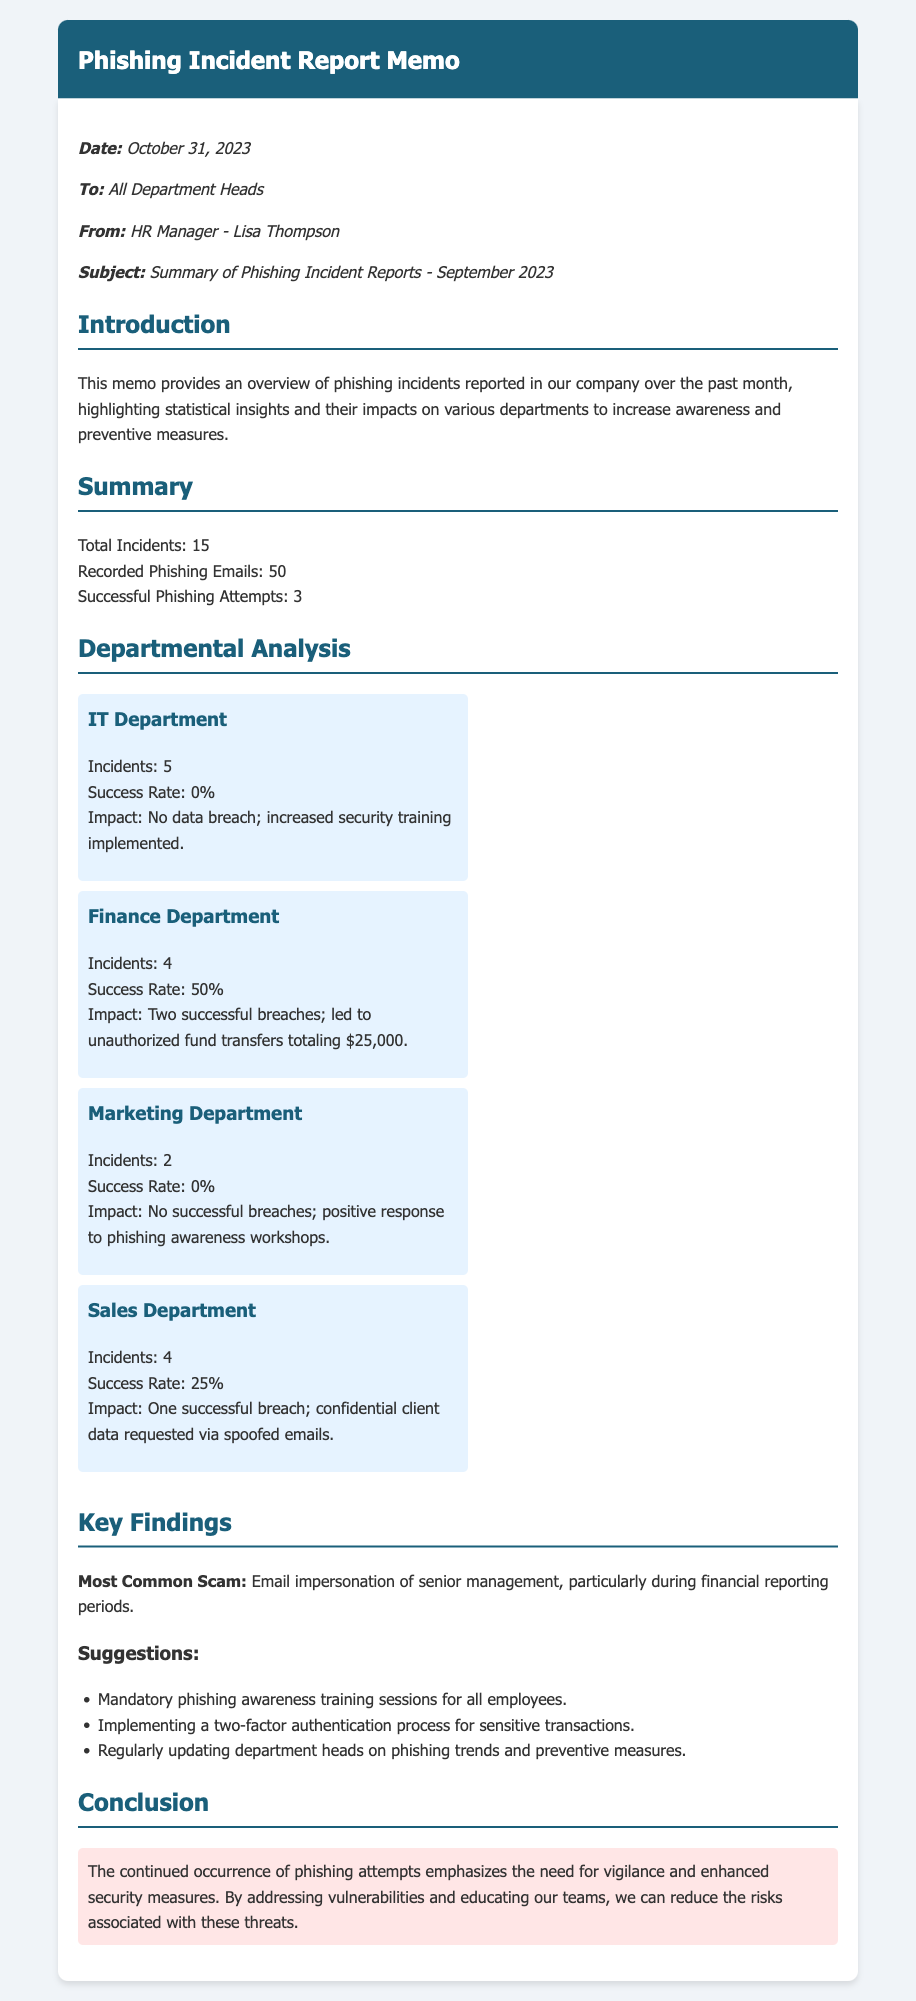What is the total number of incidents reported? The total number of incidents reported in the document is explicitly stated in the summary section.
Answer: 15 What was the success rate for the IT Department? The success rate for the IT Department is mentioned in the departmental analysis section.
Answer: 0% How much money was lost due to successful phishing attempts in the Finance Department? The financial loss due to successful phishing attempts in the Finance Department is detailed in the impact section.
Answer: $25,000 Which department experienced a successful breach? The document specifies which departments faced successful breaches in the impacts for each department.
Answer: Finance Department and Sales Department What is the most common type of phishing scam identified? The document highlights the most common scam in the key findings section.
Answer: Email impersonation of senior management How many phishing emails were recorded? The number of recorded phishing emails is indicated in the summary section.
Answer: 50 What preventive measure is suggested regarding sensitive transactions? The memo suggests implementing a specific security process in the suggestions section.
Answer: Two-factor authentication Which department had the highest number of phishing incidents? The document outlines the number of incidents for each department, allowing for a comparison of their totals.
Answer: IT Department What was the impact on the Marketing Department? The impact on the Marketing Department is summarized in its specific analysis.
Answer: No successful breaches; positive response to phishing awareness workshops 